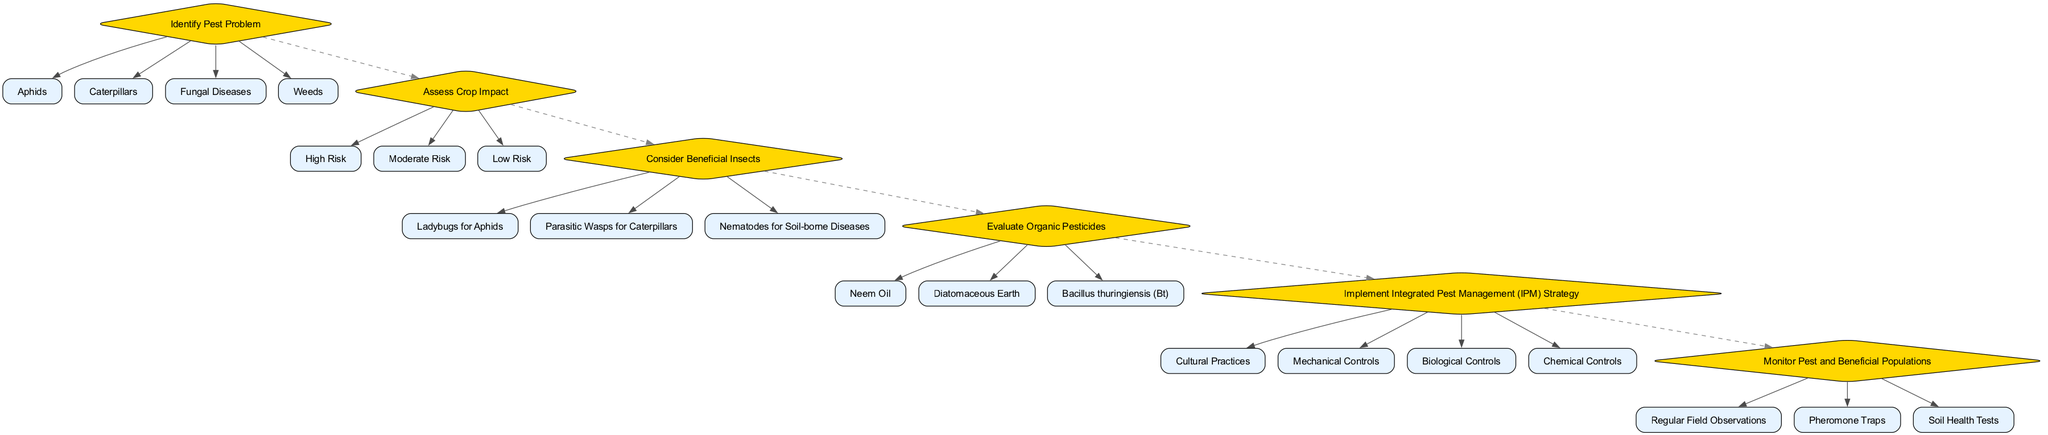What is the first decision point in the diagram? The first decision point is "Identify Pest Problem." It appears at the top of the decision tree, indicating it is the initial inquiry made before proceeding further.
Answer: Identify Pest Problem How many options are available for the "Assess Crop Impact" node? The "Assess Crop Impact" node presents three options: "High Risk," "Moderate Risk," and "Low Risk." Thus, there are three options in total.
Answer: 3 What pest control strategy includes "Cultural Practices"? The "Implement Integrated Pest Management (IPM) Strategy" node lists several strategies, and "Cultural Practices" is one of the options under this node, indicating its inclusion in the pest control strategy.
Answer: Implement Integrated Pest Management (IPM) Strategy Which beneficial insect is recommended for aphids? "Ladybugs for Aphids" is the specific beneficial insect listed under the "Consider Beneficial Insects" decision point. This indicates a direct association with controlling aphids through natural means.
Answer: Ladybugs for Aphids If the crop impact is assessed as "High Risk," what subsequent node should be addressed? After assessing the crop impact as "High Risk," the next node to consider is based on assessing pest control strategies and evaluating potential options that follow the decision flow. Therefore, it will lead to "Consider Beneficial Insects" or "Evaluate Organic Pesticides," depending on the selected path.
Answer: Consider Beneficial Insects or Evaluate Organic Pesticides Which node follows the "Evaluate Organic Pesticides"? After "Evaluate Organic Pesticides" is concluded, the next node is "Implement Integrated Pest Management (IPM) Strategy," which indicates the transition from evaluating options to strategizing their application.
Answer: Implement Integrated Pest Management (IPM) Strategy What method is used to monitor pest populations? The monitoring of pest populations involves "Regular Field Observations," "Pheromone Traps," or "Soil Health Tests," as these are all listed under the "Monitor Pest and Beneficial Populations" decision point for ongoing assessment.
Answer: Regular Field Observations, Pheromone Traps, or Soil Health Tests How many total decision points are presented in the diagram? The diagram includes a total of six decision points, each represented by a unique node along the decision-making process concerning eco-friendly pest control methods.
Answer: 6 What is the purpose of "Assess Crop Impact"? The purpose of "Assess Crop Impact" is to determine the level of risk posed to the crops by pests, allowing the decision-maker to tailor a pest control strategy based on the potential damage.
Answer: Determine pest risk level 